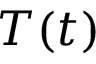<formula> <loc_0><loc_0><loc_500><loc_500>T ( t )</formula> 